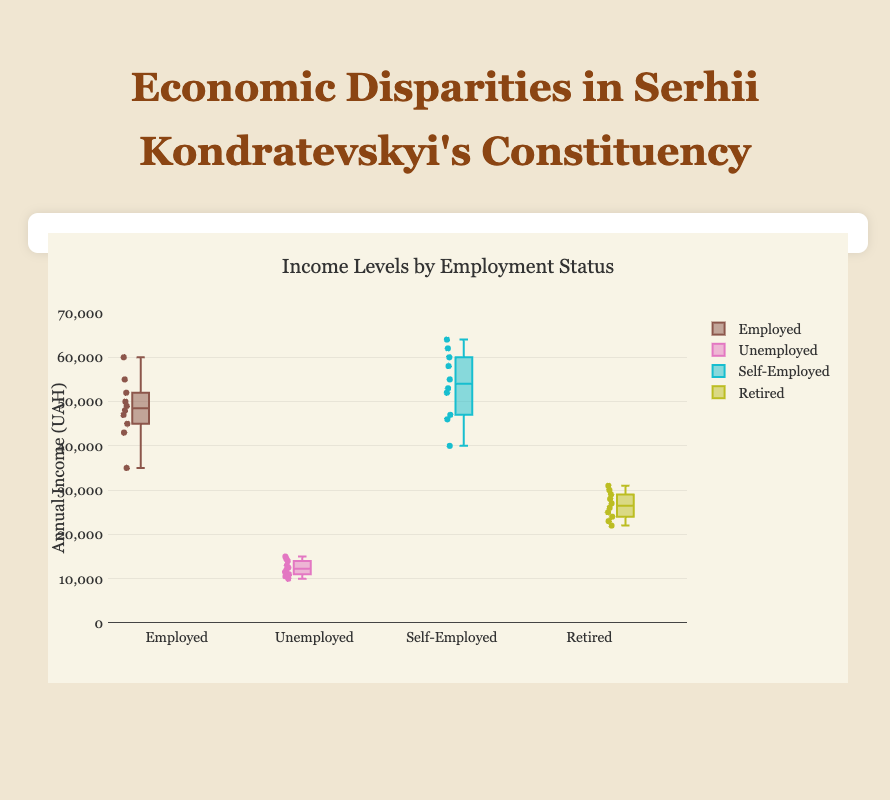What is the title of the chart? The title of the chart is displayed at the top of the figure.
Answer: Economic Disparities in Serhii Kondratevskyi's Constituency What does the y-axis represent? The y-axis title is "Annual Income (UAH)" and it displays income levels.
Answer: Annual Income (UAH) Which employment status group has the highest median income? Look for the middle line in each box which represents the median. "Self-Employed" has the highest median line compared to other groups.
Answer: Self-Employed What is the median income for the "Unemployed" group? The median is the central value of the "Unemployed" box. Refer to its middle line.
Answer: 13000 UAH Between the "Employed" and "Retired" groups, which has a higher maximum income level? Check the highest point (upper whisker) of the boxes corresponding to "Employed" and "Retired".
Answer: Employed What is the range of income for the "Self-Employed" group? The range is the difference between the highest value (upper whisker) and lowest value (lower whisker). For "Self-Employed", it's 64000 - 40000.
Answer: 24000 UAH Which employment status group has the smallest interquartile range (IQR) of incomes? The IQR is the height of the box, calculated as the difference between the third quartile and the first quartile. The "Unemployed" group has the smallest box height.
Answer: Unemployed How many outliers are visible for the "Employed" group? Outliers are individual points that fall outside the whiskers. Count these points for "Employed".
Answer: None What is the lower quartile (Q1) income level for the "Retired" group? Q1 is the lower edge of the box for the "Retired" group. Refer to this edge.
Answer: 23000 UAH Which group has the broader spread in their income data, "Employed" or "Retired"? Compare the range of the whiskers for both groups. "Employed" has a broader range from 35000 to 60000 compared to “Retired”.
Answer: Employed 